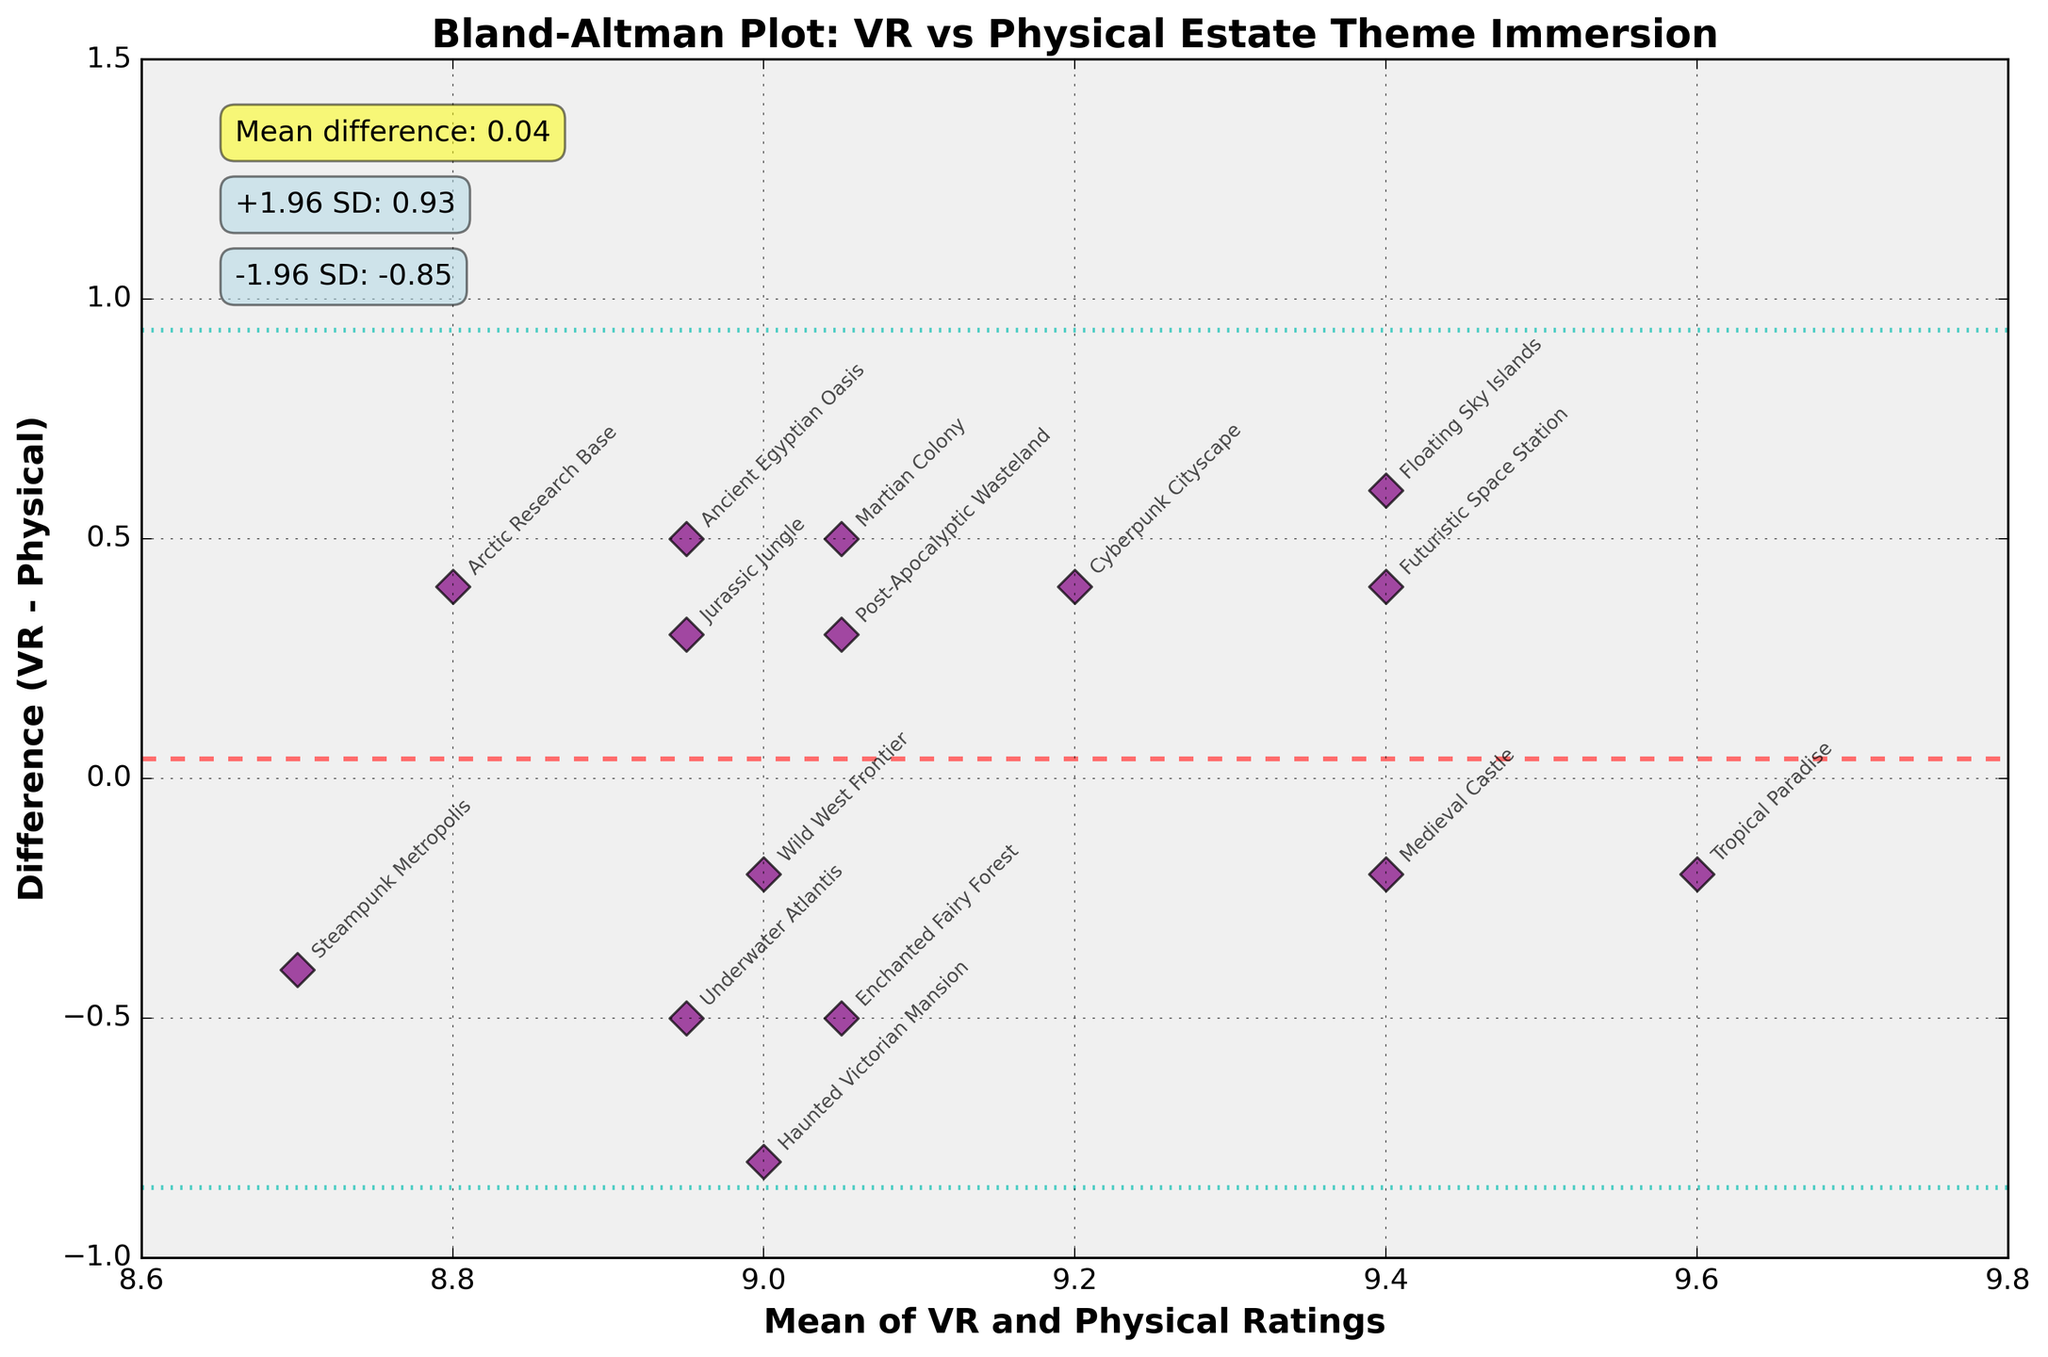What is the title of the Bland-Altman plot? The title of the plot is centered at the top in large, bold font. It states, "Bland-Altman Plot: VR vs Physical Estate Theme Immersion".
Answer: Bland-Altman Plot: VR vs Physical Estate Theme Immersion How many themes are represented in this Bland-Altman plot? There are 15 themes represented in the plot, based on the number of data points and labels present.
Answer: 15 What line is represented by the dashed line at the center of the plot? The dashed line at the center represents the mean difference of the ratings between VR and Physical experiences.
Answer: Mean difference What are the colors of the lines that represent the limits of agreement? The lines representing the limits of agreement are dashed and colored light blue.
Answer: Light blue Which theme has the largest positive difference between VR and Physical ratings? To find the largest positive difference, identify the highest point on the vertical axis of the graph. "Floating Sky Islands" has the highest difference.
Answer: Floating Sky Islands What is the mean difference between VR and Physical ratings? The mean difference is annotated on the plot in a yellow box stating "Mean difference: 0.02".
Answer: 0.02 Which theme falls closest to the mean difference line? Identify the theme whose marker is closest to the dashed mean difference line. "Underwater Atlantis" falls closest.
Answer: Underwater Atlantis What is the lower limit of agreement value? The lower limit of agreement is annotated on the plot with the value in a light blue box stating "-1.96 SD: -0.45".
Answer: -0.45 What is the upper limit of agreement value? The upper limit of agreement is annotated on the plot with the value in a light blue box stating "+1.96 SD: 0.49".
Answer: 0.49 Which theme has a VR rating higher than its Physical rating and how much greater is it? Identify themes above the mean difference line where the VR rating is higher than the Physical rating. "Floating Sky Islands" has a VR rating 0.6 units higher (10.7 - 10.1).
Answer: Floating Sky Islands, 0.6 